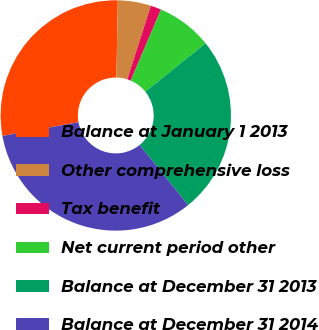Convert chart. <chart><loc_0><loc_0><loc_500><loc_500><pie_chart><fcel>Balance at January 1 2013<fcel>Other comprehensive loss<fcel>Tax benefit<fcel>Net current period other<fcel>Balance at December 31 2013<fcel>Balance at December 31 2014<nl><fcel>28.12%<fcel>4.65%<fcel>1.5%<fcel>7.8%<fcel>24.97%<fcel>32.96%<nl></chart> 